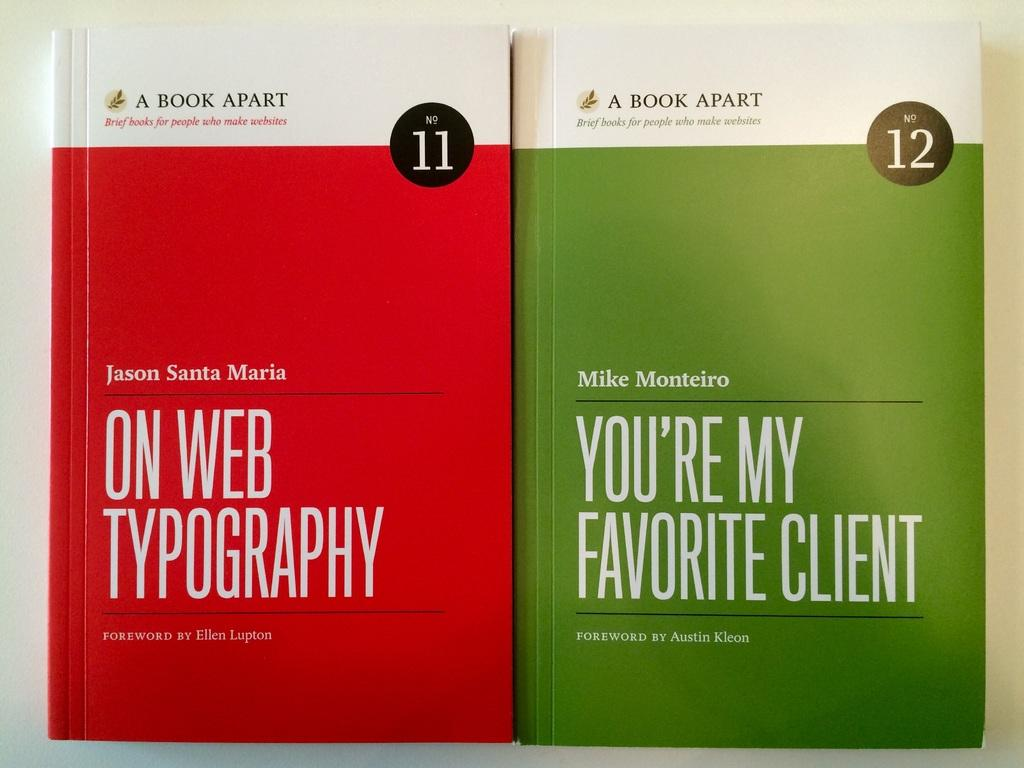How many books are visible in the image? There are two books in the image. Where are the books located in the image? The books are placed on a surface. What is the name of the book that is on a voyage in the image? There is no book on a voyage in the image; the books are simply placed on a surface. 